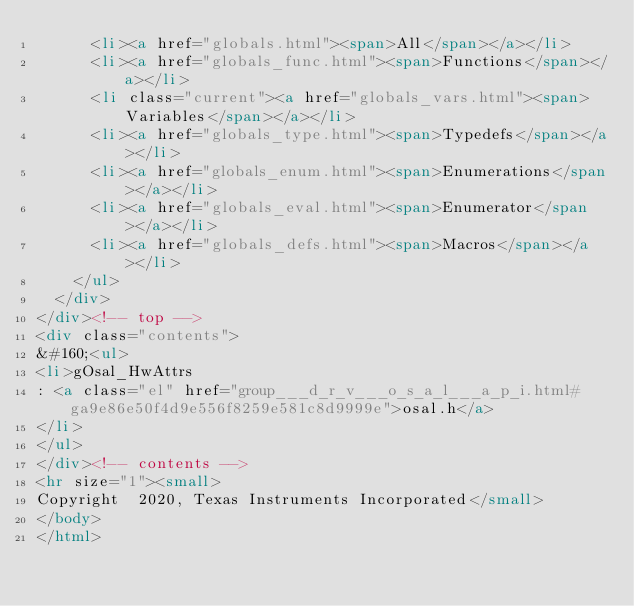<code> <loc_0><loc_0><loc_500><loc_500><_HTML_>      <li><a href="globals.html"><span>All</span></a></li>
      <li><a href="globals_func.html"><span>Functions</span></a></li>
      <li class="current"><a href="globals_vars.html"><span>Variables</span></a></li>
      <li><a href="globals_type.html"><span>Typedefs</span></a></li>
      <li><a href="globals_enum.html"><span>Enumerations</span></a></li>
      <li><a href="globals_eval.html"><span>Enumerator</span></a></li>
      <li><a href="globals_defs.html"><span>Macros</span></a></li>
    </ul>
  </div>
</div><!-- top -->
<div class="contents">
&#160;<ul>
<li>gOsal_HwAttrs
: <a class="el" href="group___d_r_v___o_s_a_l___a_p_i.html#ga9e86e50f4d9e556f8259e581c8d9999e">osal.h</a>
</li>
</ul>
</div><!-- contents -->
<hr size="1"><small>
Copyright  2020, Texas Instruments Incorporated</small>
</body>
</html>
</code> 